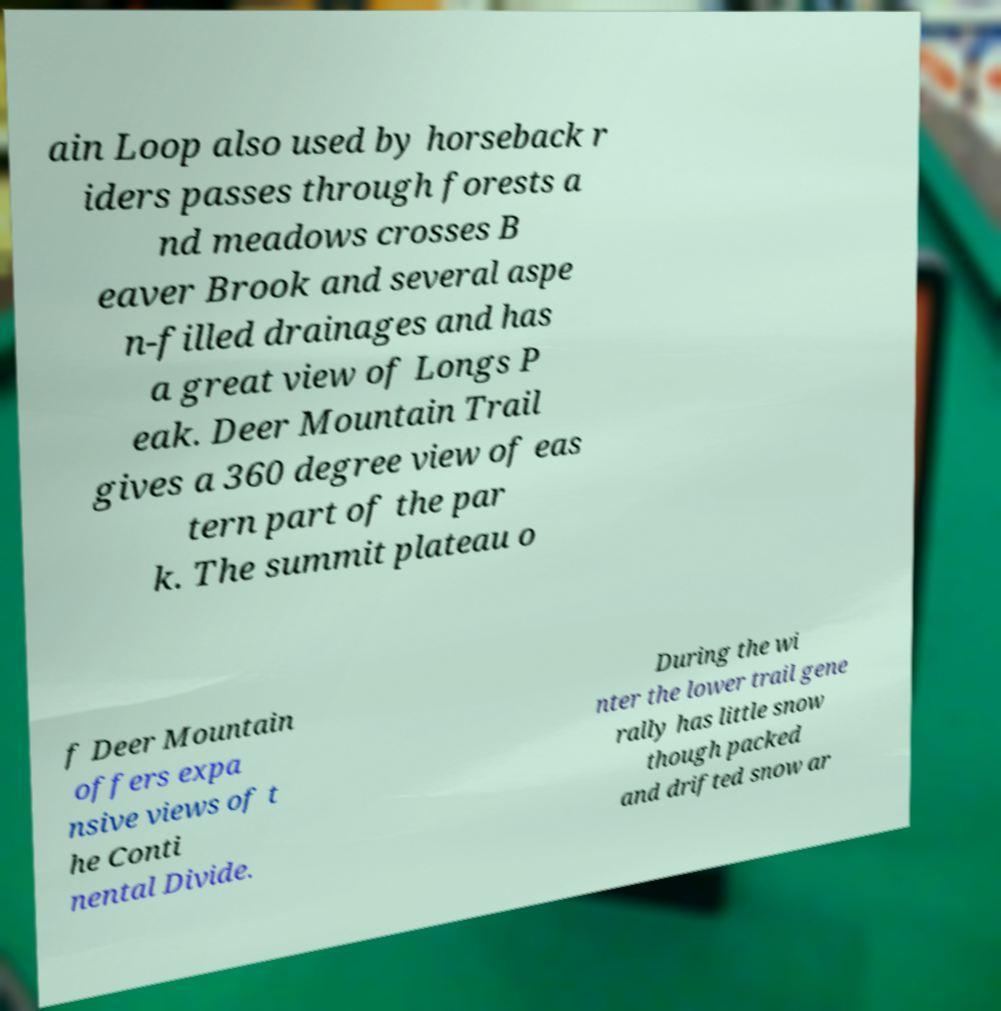Could you extract and type out the text from this image? ain Loop also used by horseback r iders passes through forests a nd meadows crosses B eaver Brook and several aspe n-filled drainages and has a great view of Longs P eak. Deer Mountain Trail gives a 360 degree view of eas tern part of the par k. The summit plateau o f Deer Mountain offers expa nsive views of t he Conti nental Divide. During the wi nter the lower trail gene rally has little snow though packed and drifted snow ar 